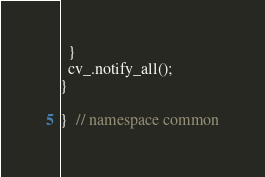Convert code to text. <code><loc_0><loc_0><loc_500><loc_500><_C++_>  }
  cv_.notify_all();
}

}  // namespace common
</code> 